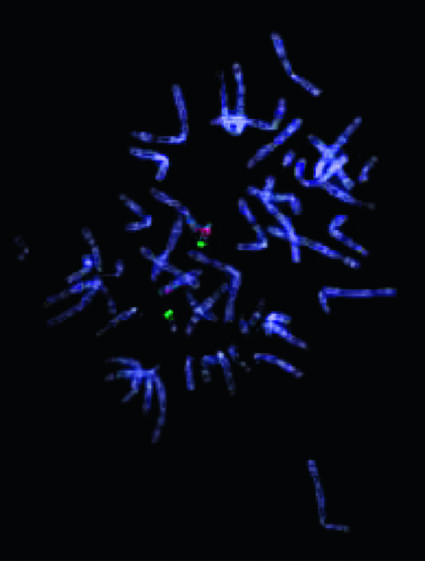does this abnormality give rise to the 22q11 .2 deletion syndrome digeorge syndrome?
Answer the question using a single word or phrase. Yes 